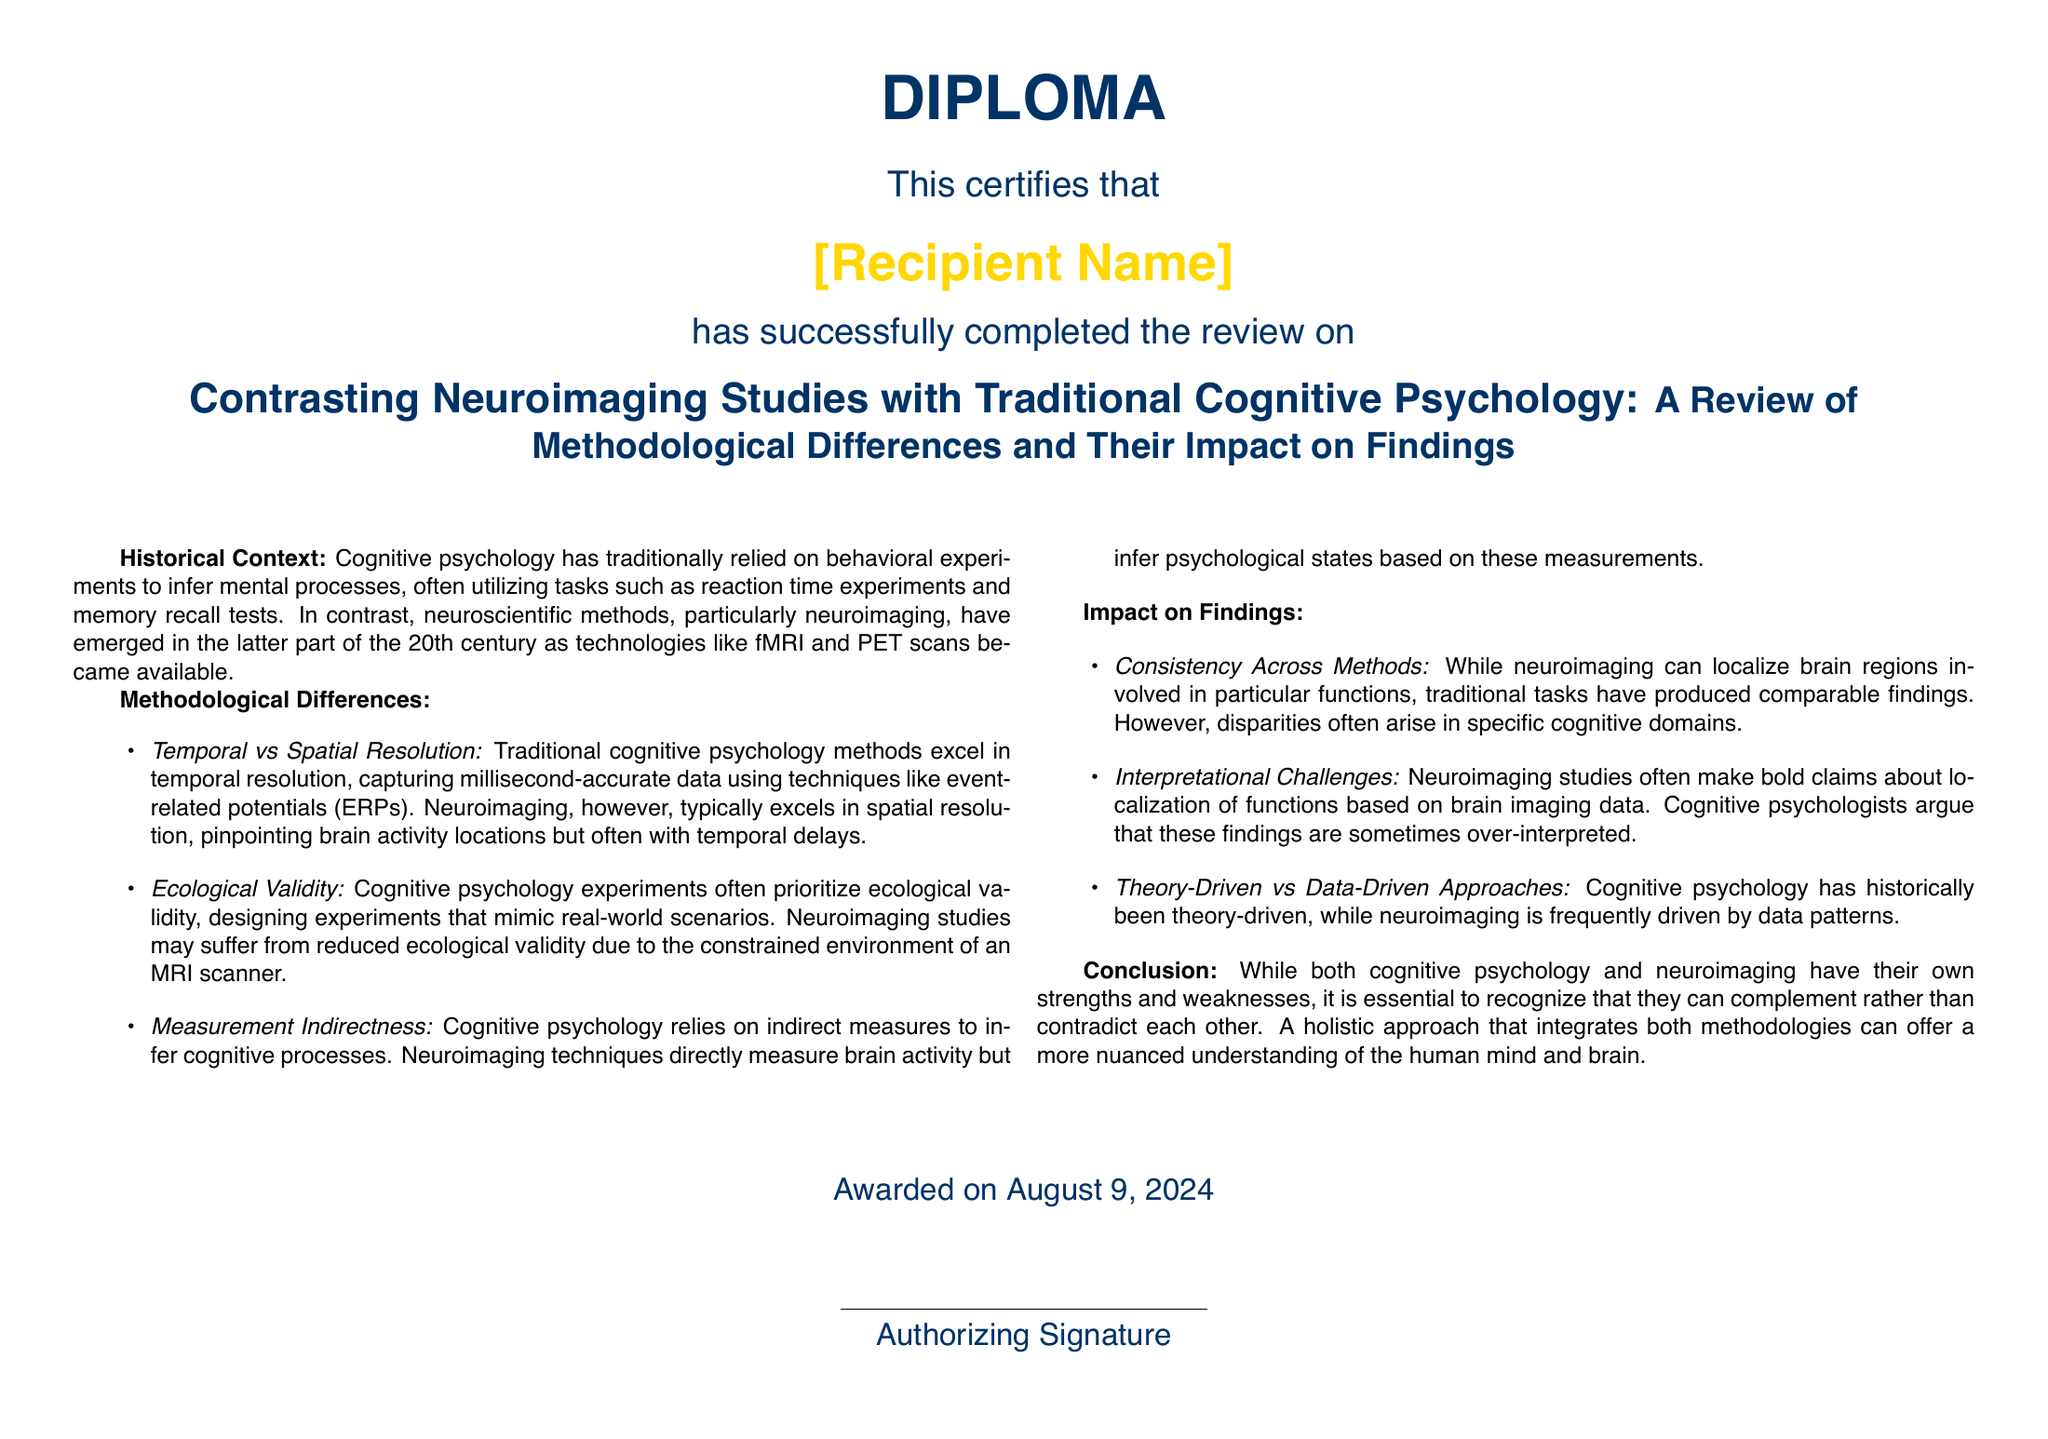What is the recipient name? The recipient name appears in the document but is not specified as it is a placeholder.
Answer: [Recipient Name] What is the title of the review? The title of the review is directly stated in the document.
Answer: Contrasting Neuroimaging Studies with Traditional Cognitive Psychology: A Review of Methodological Differences and Their Impact on Findings When was the diploma awarded? The specific date is indicated in the document as "today".
Answer: today What are the two main methodologies discussed? The document states the two methodologies being contrasted.
Answer: Cognitive psychology and neuroimaging What type of resolution do traditional cognitive psychology methods excel in? The document mentions that traditional methods excel in temporal resolution.
Answer: Temporal resolution What is a challenge mentioned regarding neuroimaging studies? The document highlights interpretational challenges specific to neuroimaging.
Answer: Interpretational challenges Which approach is described as typically theory-driven? The document asserts that cognitive psychology has historically been theory-driven.
Answer: Cognitive psychology What kind of validity do cognitive psychology experiments prioritize? The document specifies that ecological validity is prioritized in cognitive psychology.
Answer: Ecological validity What kind of measures does cognitive psychology rely on? The document indicates that cognitive psychology relies on indirect measures to infer processes.
Answer: Indirect measures 